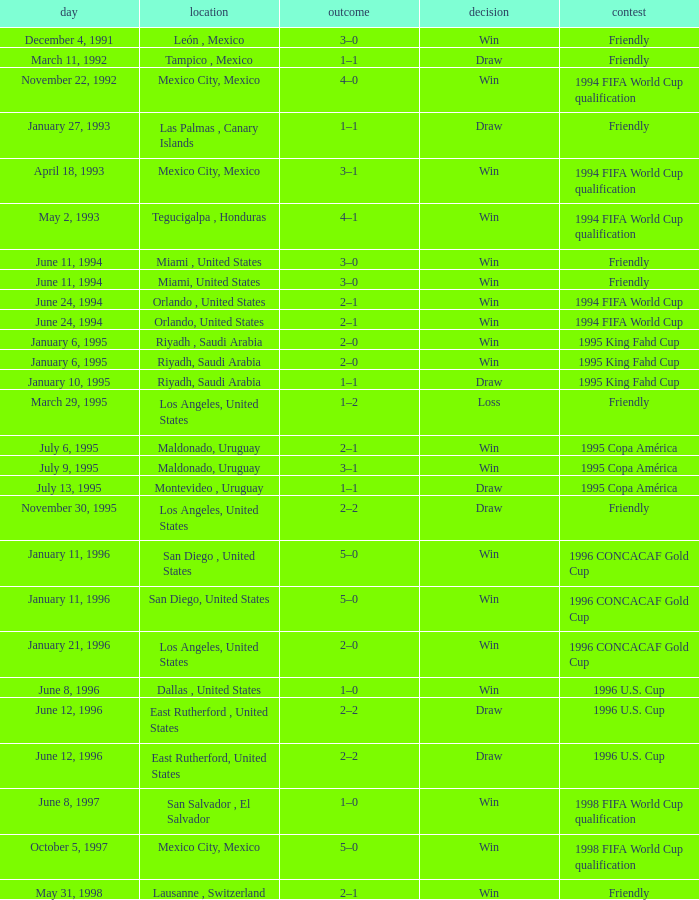What is Venue, when Date is "January 6, 1995"? Riyadh , Saudi Arabia, Riyadh, Saudi Arabia. 